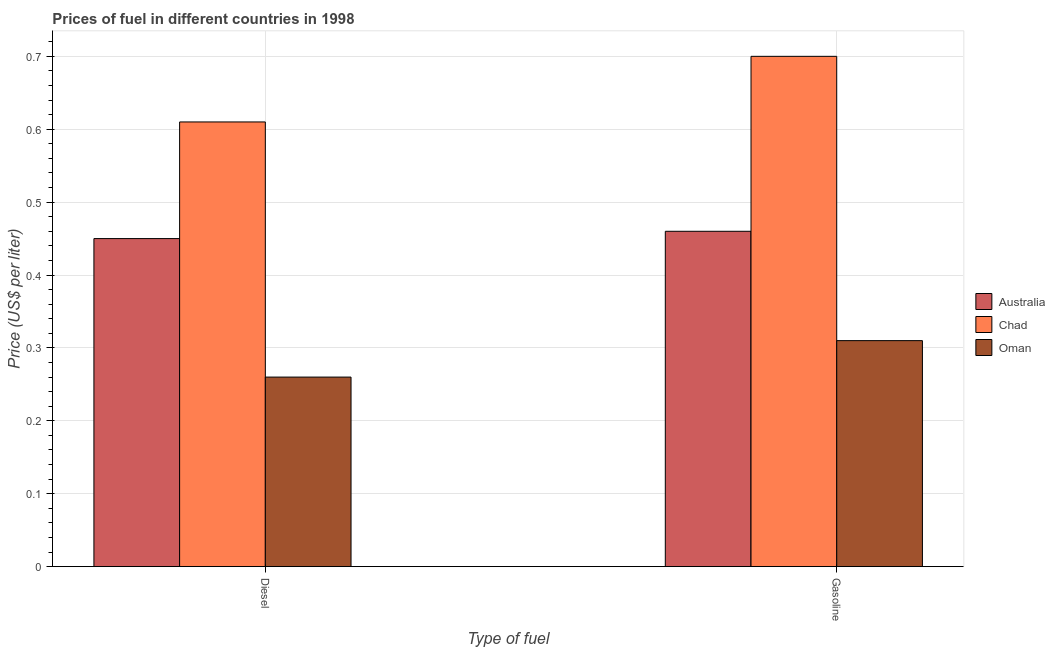How many different coloured bars are there?
Keep it short and to the point. 3. Are the number of bars on each tick of the X-axis equal?
Provide a short and direct response. Yes. How many bars are there on the 1st tick from the left?
Your answer should be compact. 3. What is the label of the 1st group of bars from the left?
Give a very brief answer. Diesel. What is the diesel price in Oman?
Provide a short and direct response. 0.26. Across all countries, what is the maximum diesel price?
Provide a short and direct response. 0.61. Across all countries, what is the minimum gasoline price?
Provide a short and direct response. 0.31. In which country was the diesel price maximum?
Your answer should be compact. Chad. In which country was the gasoline price minimum?
Make the answer very short. Oman. What is the total diesel price in the graph?
Keep it short and to the point. 1.32. What is the difference between the diesel price in Australia and that in Chad?
Make the answer very short. -0.16. What is the difference between the gasoline price in Australia and the diesel price in Chad?
Offer a very short reply. -0.15. What is the average gasoline price per country?
Keep it short and to the point. 0.49. What is the difference between the diesel price and gasoline price in Oman?
Make the answer very short. -0.05. In how many countries, is the gasoline price greater than 0.5 US$ per litre?
Keep it short and to the point. 1. What is the ratio of the gasoline price in Oman to that in Australia?
Offer a terse response. 0.67. In how many countries, is the gasoline price greater than the average gasoline price taken over all countries?
Your answer should be very brief. 1. What does the 1st bar from the left in Diesel represents?
Provide a short and direct response. Australia. What does the 3rd bar from the right in Diesel represents?
Offer a very short reply. Australia. How many bars are there?
Your response must be concise. 6. Are all the bars in the graph horizontal?
Your answer should be very brief. No. Are the values on the major ticks of Y-axis written in scientific E-notation?
Provide a succinct answer. No. Does the graph contain any zero values?
Your answer should be very brief. No. Where does the legend appear in the graph?
Give a very brief answer. Center right. How many legend labels are there?
Make the answer very short. 3. How are the legend labels stacked?
Ensure brevity in your answer.  Vertical. What is the title of the graph?
Provide a succinct answer. Prices of fuel in different countries in 1998. Does "Guyana" appear as one of the legend labels in the graph?
Offer a very short reply. No. What is the label or title of the X-axis?
Provide a succinct answer. Type of fuel. What is the label or title of the Y-axis?
Offer a very short reply. Price (US$ per liter). What is the Price (US$ per liter) in Australia in Diesel?
Provide a short and direct response. 0.45. What is the Price (US$ per liter) in Chad in Diesel?
Provide a short and direct response. 0.61. What is the Price (US$ per liter) in Oman in Diesel?
Your response must be concise. 0.26. What is the Price (US$ per liter) in Australia in Gasoline?
Provide a short and direct response. 0.46. What is the Price (US$ per liter) in Oman in Gasoline?
Your answer should be compact. 0.31. Across all Type of fuel, what is the maximum Price (US$ per liter) in Australia?
Your response must be concise. 0.46. Across all Type of fuel, what is the maximum Price (US$ per liter) of Oman?
Provide a short and direct response. 0.31. Across all Type of fuel, what is the minimum Price (US$ per liter) of Australia?
Your answer should be very brief. 0.45. Across all Type of fuel, what is the minimum Price (US$ per liter) in Chad?
Offer a terse response. 0.61. Across all Type of fuel, what is the minimum Price (US$ per liter) in Oman?
Give a very brief answer. 0.26. What is the total Price (US$ per liter) in Australia in the graph?
Keep it short and to the point. 0.91. What is the total Price (US$ per liter) of Chad in the graph?
Keep it short and to the point. 1.31. What is the total Price (US$ per liter) in Oman in the graph?
Provide a short and direct response. 0.57. What is the difference between the Price (US$ per liter) in Australia in Diesel and that in Gasoline?
Your answer should be compact. -0.01. What is the difference between the Price (US$ per liter) of Chad in Diesel and that in Gasoline?
Your response must be concise. -0.09. What is the difference between the Price (US$ per liter) in Australia in Diesel and the Price (US$ per liter) in Chad in Gasoline?
Provide a short and direct response. -0.25. What is the difference between the Price (US$ per liter) in Australia in Diesel and the Price (US$ per liter) in Oman in Gasoline?
Provide a short and direct response. 0.14. What is the average Price (US$ per liter) of Australia per Type of fuel?
Provide a short and direct response. 0.46. What is the average Price (US$ per liter) in Chad per Type of fuel?
Make the answer very short. 0.66. What is the average Price (US$ per liter) in Oman per Type of fuel?
Ensure brevity in your answer.  0.28. What is the difference between the Price (US$ per liter) in Australia and Price (US$ per liter) in Chad in Diesel?
Keep it short and to the point. -0.16. What is the difference between the Price (US$ per liter) in Australia and Price (US$ per liter) in Oman in Diesel?
Make the answer very short. 0.19. What is the difference between the Price (US$ per liter) of Australia and Price (US$ per liter) of Chad in Gasoline?
Offer a very short reply. -0.24. What is the difference between the Price (US$ per liter) in Australia and Price (US$ per liter) in Oman in Gasoline?
Keep it short and to the point. 0.15. What is the difference between the Price (US$ per liter) in Chad and Price (US$ per liter) in Oman in Gasoline?
Make the answer very short. 0.39. What is the ratio of the Price (US$ per liter) of Australia in Diesel to that in Gasoline?
Your answer should be compact. 0.98. What is the ratio of the Price (US$ per liter) in Chad in Diesel to that in Gasoline?
Offer a very short reply. 0.87. What is the ratio of the Price (US$ per liter) of Oman in Diesel to that in Gasoline?
Provide a succinct answer. 0.84. What is the difference between the highest and the second highest Price (US$ per liter) of Australia?
Give a very brief answer. 0.01. What is the difference between the highest and the second highest Price (US$ per liter) of Chad?
Your answer should be compact. 0.09. What is the difference between the highest and the lowest Price (US$ per liter) in Chad?
Keep it short and to the point. 0.09. What is the difference between the highest and the lowest Price (US$ per liter) of Oman?
Give a very brief answer. 0.05. 